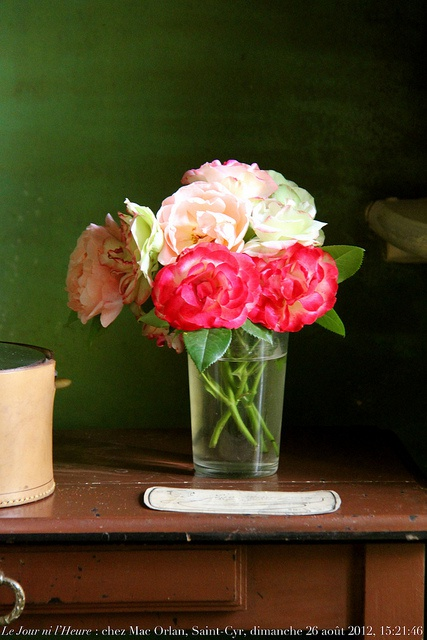Describe the objects in this image and their specific colors. I can see vase in darkgreen, black, olive, and gray tones and cup in darkgreen, tan, and black tones in this image. 